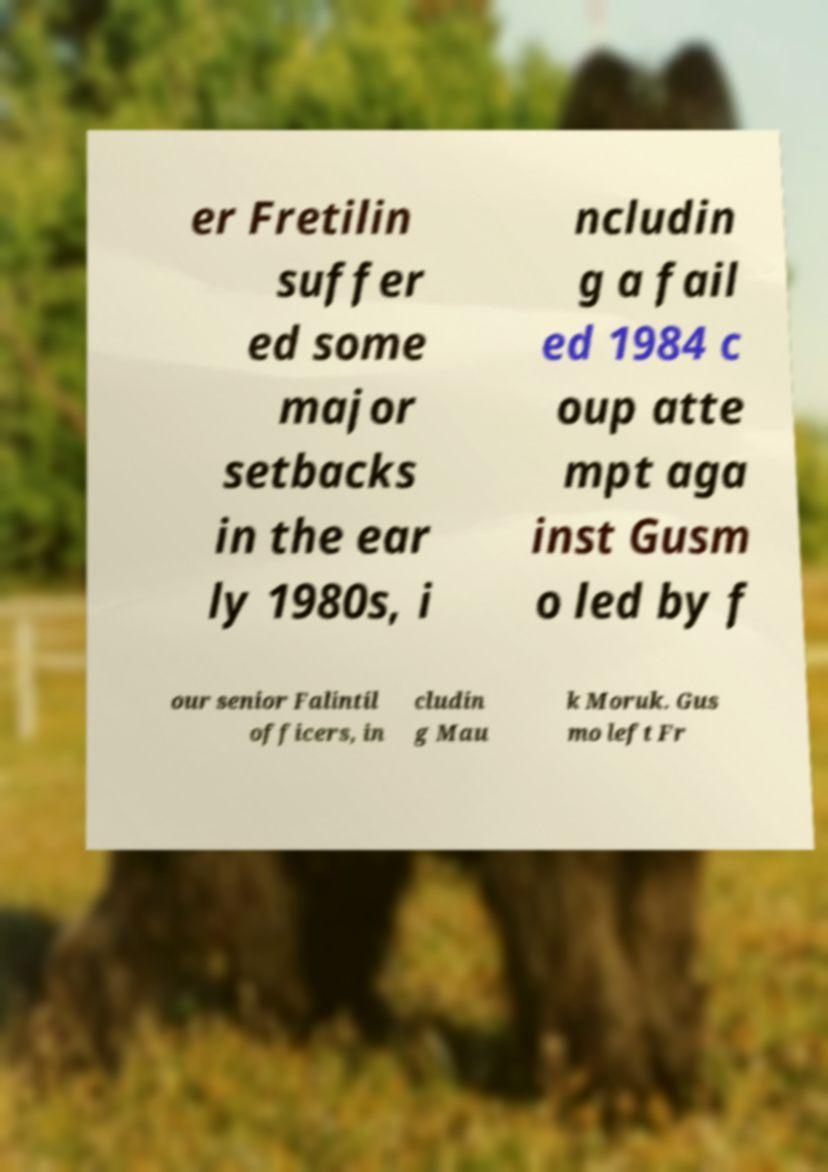There's text embedded in this image that I need extracted. Can you transcribe it verbatim? er Fretilin suffer ed some major setbacks in the ear ly 1980s, i ncludin g a fail ed 1984 c oup atte mpt aga inst Gusm o led by f our senior Falintil officers, in cludin g Mau k Moruk. Gus mo left Fr 